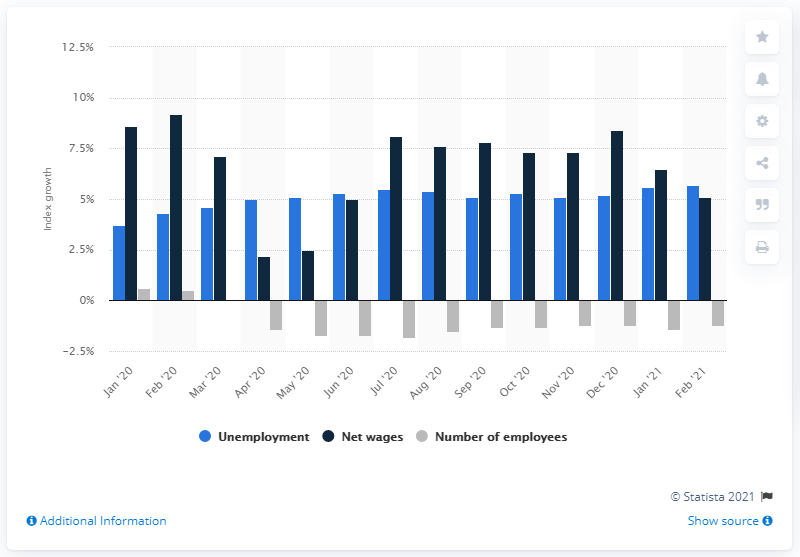Indicate a few pertinent items in this graphic. The unemployment rate in February 2021 was 5.7%. 